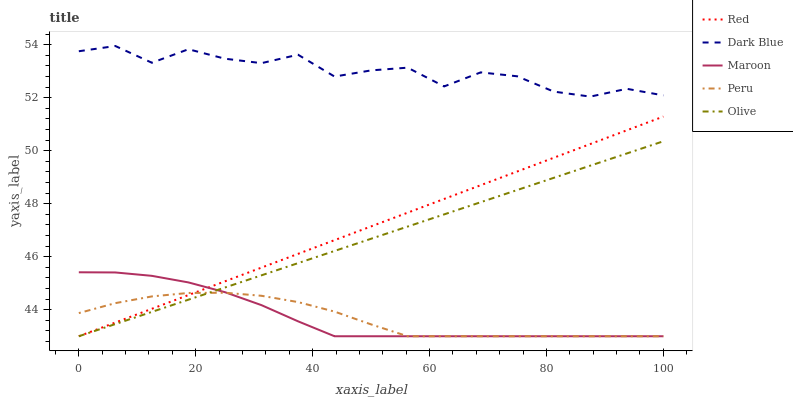Does Maroon have the minimum area under the curve?
Answer yes or no. No. Does Maroon have the maximum area under the curve?
Answer yes or no. No. Is Maroon the smoothest?
Answer yes or no. No. Is Maroon the roughest?
Answer yes or no. No. Does Dark Blue have the lowest value?
Answer yes or no. No. Does Maroon have the highest value?
Answer yes or no. No. Is Olive less than Dark Blue?
Answer yes or no. Yes. Is Dark Blue greater than Red?
Answer yes or no. Yes. Does Olive intersect Dark Blue?
Answer yes or no. No. 